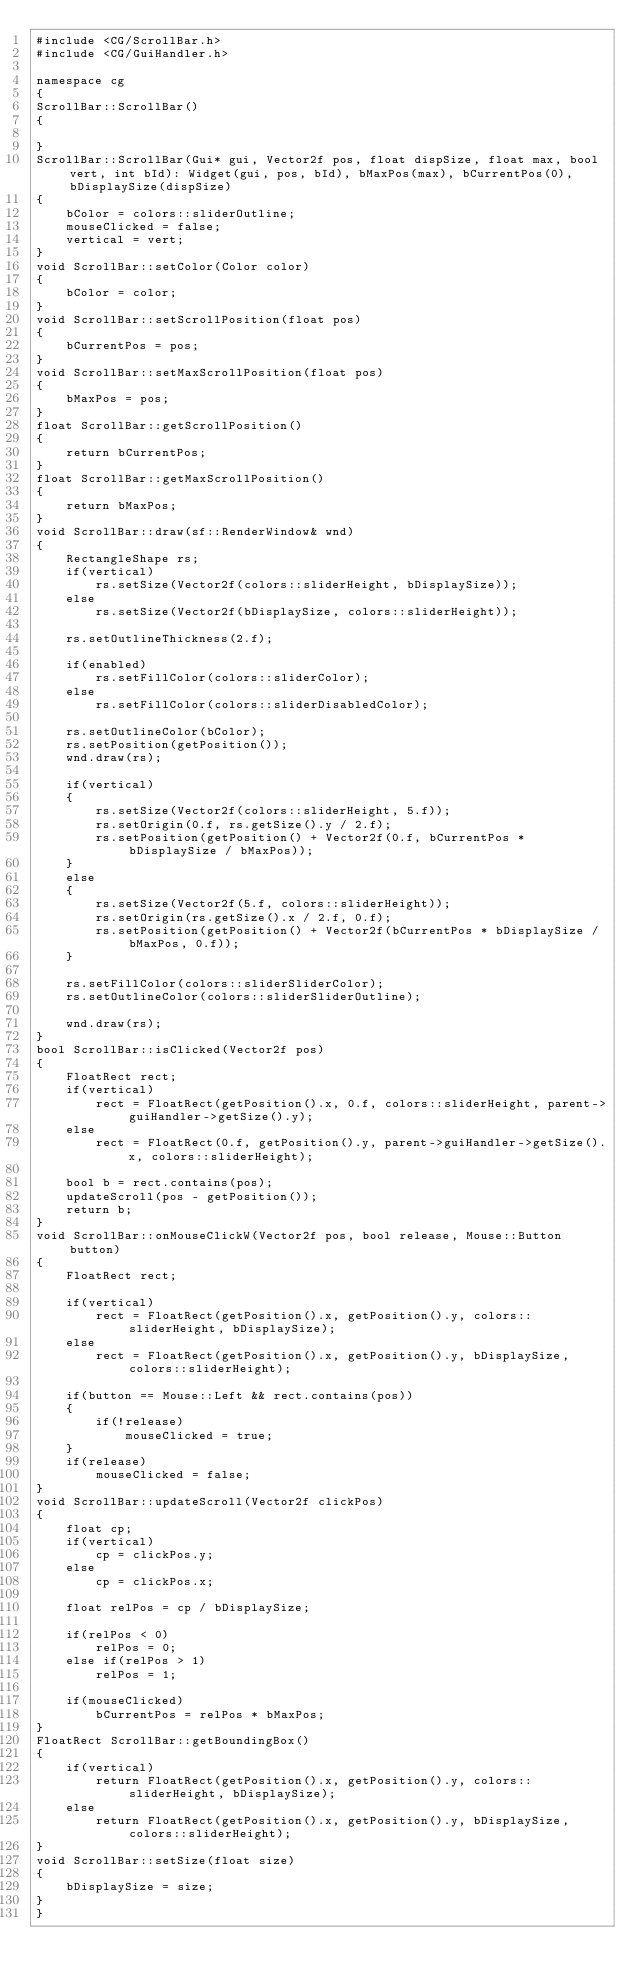<code> <loc_0><loc_0><loc_500><loc_500><_C++_>#include <CG/ScrollBar.h>
#include <CG/GuiHandler.h>

namespace cg
{
ScrollBar::ScrollBar()
{

}
ScrollBar::ScrollBar(Gui* gui, Vector2f pos, float dispSize, float max, bool vert, int bId): Widget(gui, pos, bId), bMaxPos(max), bCurrentPos(0), bDisplaySize(dispSize)
{
    bColor = colors::sliderOutline;
    mouseClicked = false;
    vertical = vert;
}
void ScrollBar::setColor(Color color)
{
    bColor = color;
}
void ScrollBar::setScrollPosition(float pos)
{
    bCurrentPos = pos;
}
void ScrollBar::setMaxScrollPosition(float pos)
{
    bMaxPos = pos;
}
float ScrollBar::getScrollPosition()
{
    return bCurrentPos;
}
float ScrollBar::getMaxScrollPosition()
{
    return bMaxPos;
}
void ScrollBar::draw(sf::RenderWindow& wnd)
{
    RectangleShape rs;
    if(vertical)
        rs.setSize(Vector2f(colors::sliderHeight, bDisplaySize));
    else
        rs.setSize(Vector2f(bDisplaySize, colors::sliderHeight));

    rs.setOutlineThickness(2.f);

    if(enabled)
        rs.setFillColor(colors::sliderColor);
    else
        rs.setFillColor(colors::sliderDisabledColor);

    rs.setOutlineColor(bColor);
    rs.setPosition(getPosition());
    wnd.draw(rs);

    if(vertical)
    {
        rs.setSize(Vector2f(colors::sliderHeight, 5.f));
        rs.setOrigin(0.f, rs.getSize().y / 2.f);
        rs.setPosition(getPosition() + Vector2f(0.f, bCurrentPos * bDisplaySize / bMaxPos));
    }
    else
    {
        rs.setSize(Vector2f(5.f, colors::sliderHeight));
        rs.setOrigin(rs.getSize().x / 2.f, 0.f);
        rs.setPosition(getPosition() + Vector2f(bCurrentPos * bDisplaySize / bMaxPos, 0.f));
    }

    rs.setFillColor(colors::sliderSliderColor);
    rs.setOutlineColor(colors::sliderSliderOutline);

    wnd.draw(rs);
}
bool ScrollBar::isClicked(Vector2f pos)
{
    FloatRect rect;
    if(vertical)
        rect = FloatRect(getPosition().x, 0.f, colors::sliderHeight, parent->guiHandler->getSize().y);
    else
        rect = FloatRect(0.f, getPosition().y, parent->guiHandler->getSize().x, colors::sliderHeight);

    bool b = rect.contains(pos);
    updateScroll(pos - getPosition());
    return b;
}
void ScrollBar::onMouseClickW(Vector2f pos, bool release, Mouse::Button button)
{
    FloatRect rect;

    if(vertical)
        rect = FloatRect(getPosition().x, getPosition().y, colors::sliderHeight, bDisplaySize);
    else
        rect = FloatRect(getPosition().x, getPosition().y, bDisplaySize, colors::sliderHeight);

    if(button == Mouse::Left && rect.contains(pos))
    {
        if(!release)
            mouseClicked = true;
    }
    if(release)
        mouseClicked = false;
}
void ScrollBar::updateScroll(Vector2f clickPos)
{
    float cp;
    if(vertical)
        cp = clickPos.y;
    else
        cp = clickPos.x;

    float relPos = cp / bDisplaySize;

    if(relPos < 0)
        relPos = 0;
    else if(relPos > 1)
        relPos = 1;

    if(mouseClicked)
        bCurrentPos = relPos * bMaxPos;
}
FloatRect ScrollBar::getBoundingBox()
{
    if(vertical)
        return FloatRect(getPosition().x, getPosition().y, colors::sliderHeight, bDisplaySize);
    else
        return FloatRect(getPosition().x, getPosition().y, bDisplaySize, colors::sliderHeight);
}
void ScrollBar::setSize(float size)
{
    bDisplaySize = size;
}
}
</code> 